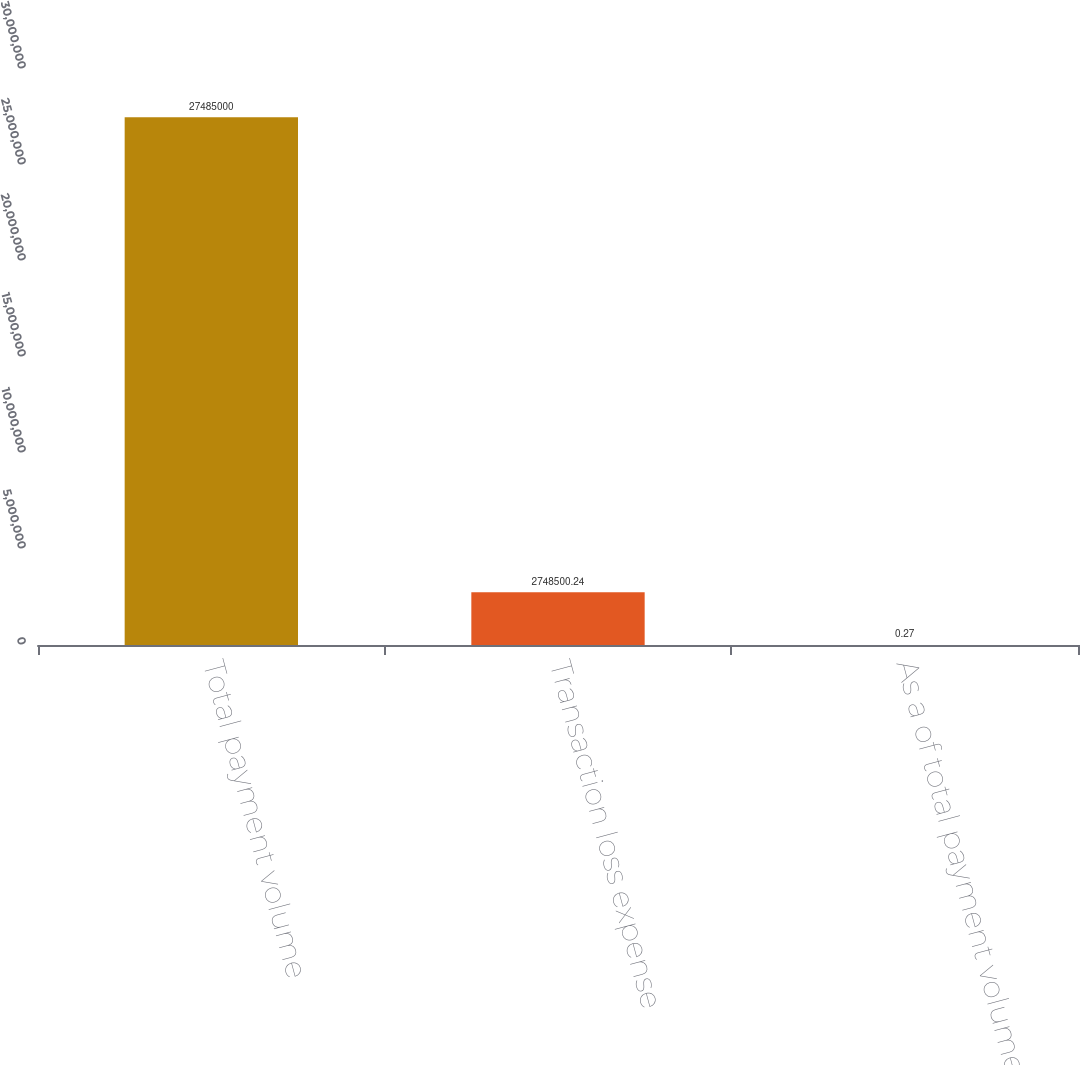Convert chart. <chart><loc_0><loc_0><loc_500><loc_500><bar_chart><fcel>Total payment volume<fcel>Transaction loss expense<fcel>As a of total payment volume<nl><fcel>2.7485e+07<fcel>2.7485e+06<fcel>0.27<nl></chart> 